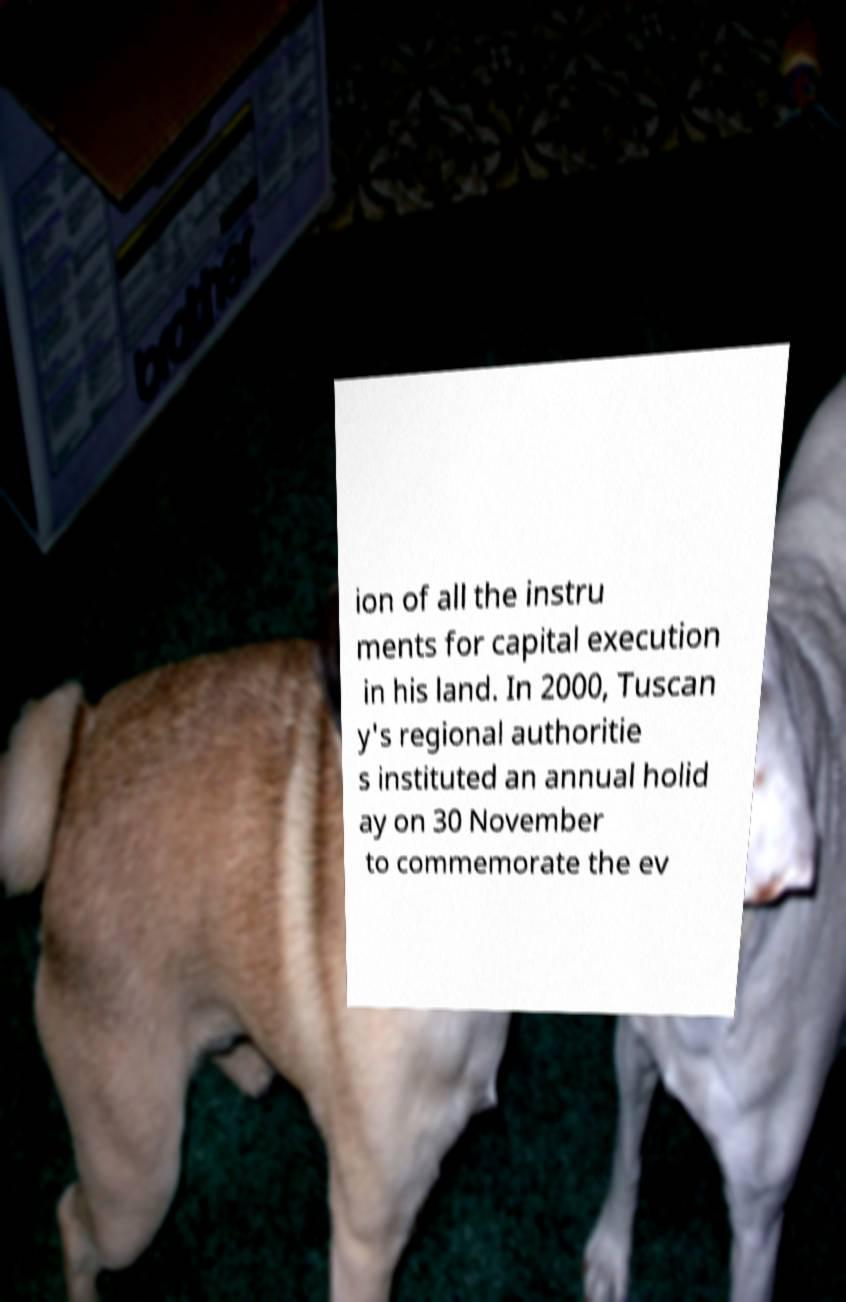Please identify and transcribe the text found in this image. ion of all the instru ments for capital execution in his land. In 2000, Tuscan y's regional authoritie s instituted an annual holid ay on 30 November to commemorate the ev 